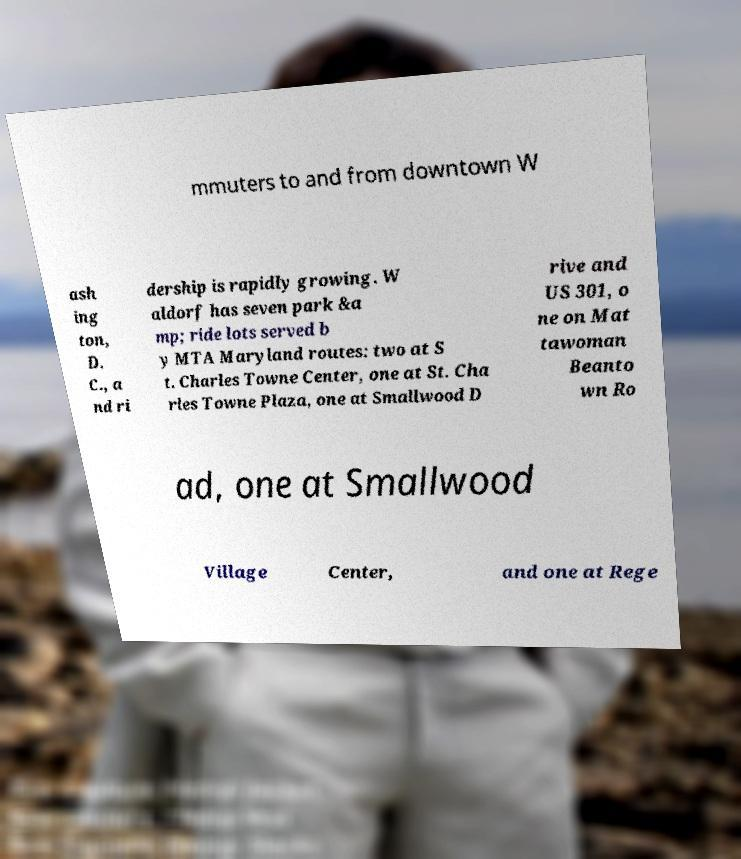Can you accurately transcribe the text from the provided image for me? mmuters to and from downtown W ash ing ton, D. C., a nd ri dership is rapidly growing. W aldorf has seven park &a mp; ride lots served b y MTA Maryland routes: two at S t. Charles Towne Center, one at St. Cha rles Towne Plaza, one at Smallwood D rive and US 301, o ne on Mat tawoman Beanto wn Ro ad, one at Smallwood Village Center, and one at Rege 